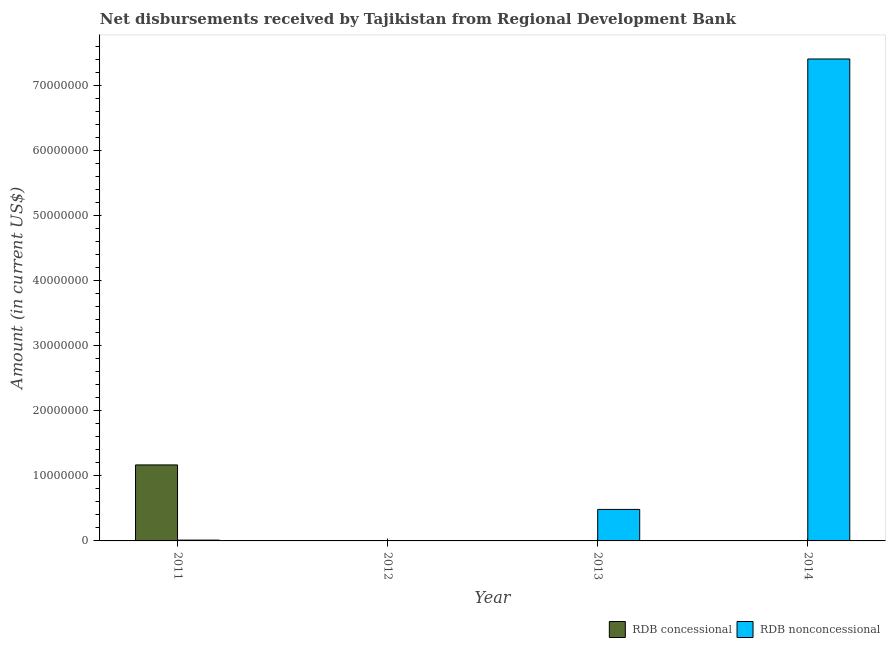Are the number of bars per tick equal to the number of legend labels?
Provide a succinct answer. No. How many bars are there on the 3rd tick from the left?
Ensure brevity in your answer.  1. How many bars are there on the 3rd tick from the right?
Keep it short and to the point. 0. What is the label of the 3rd group of bars from the left?
Offer a very short reply. 2013. Across all years, what is the maximum net non concessional disbursements from rdb?
Your answer should be compact. 7.41e+07. In which year was the net non concessional disbursements from rdb maximum?
Your answer should be compact. 2014. What is the total net concessional disbursements from rdb in the graph?
Give a very brief answer. 1.17e+07. What is the difference between the net non concessional disbursements from rdb in 2011 and that in 2013?
Your response must be concise. -4.72e+06. What is the difference between the net non concessional disbursements from rdb in 2012 and the net concessional disbursements from rdb in 2013?
Offer a terse response. -4.84e+06. What is the average net concessional disbursements from rdb per year?
Your answer should be compact. 2.92e+06. In how many years, is the net non concessional disbursements from rdb greater than 6000000 US$?
Keep it short and to the point. 1. Is the net non concessional disbursements from rdb in 2011 less than that in 2013?
Offer a very short reply. Yes. Is the difference between the net non concessional disbursements from rdb in 2013 and 2014 greater than the difference between the net concessional disbursements from rdb in 2013 and 2014?
Your response must be concise. No. What is the difference between the highest and the second highest net non concessional disbursements from rdb?
Keep it short and to the point. 6.92e+07. What is the difference between the highest and the lowest net non concessional disbursements from rdb?
Give a very brief answer. 7.41e+07. Is the sum of the net non concessional disbursements from rdb in 2011 and 2014 greater than the maximum net concessional disbursements from rdb across all years?
Give a very brief answer. Yes. How many bars are there?
Your answer should be very brief. 4. How many years are there in the graph?
Ensure brevity in your answer.  4. What is the difference between two consecutive major ticks on the Y-axis?
Your answer should be compact. 1.00e+07. Does the graph contain any zero values?
Your response must be concise. Yes. Does the graph contain grids?
Give a very brief answer. No. Where does the legend appear in the graph?
Your answer should be very brief. Bottom right. How are the legend labels stacked?
Give a very brief answer. Horizontal. What is the title of the graph?
Offer a very short reply. Net disbursements received by Tajikistan from Regional Development Bank. What is the label or title of the Y-axis?
Give a very brief answer. Amount (in current US$). What is the Amount (in current US$) of RDB concessional in 2011?
Ensure brevity in your answer.  1.17e+07. What is the Amount (in current US$) of RDB nonconcessional in 2011?
Make the answer very short. 1.25e+05. What is the Amount (in current US$) in RDB nonconcessional in 2012?
Provide a succinct answer. 0. What is the Amount (in current US$) in RDB concessional in 2013?
Provide a succinct answer. 0. What is the Amount (in current US$) of RDB nonconcessional in 2013?
Your response must be concise. 4.84e+06. What is the Amount (in current US$) of RDB nonconcessional in 2014?
Your response must be concise. 7.41e+07. Across all years, what is the maximum Amount (in current US$) in RDB concessional?
Make the answer very short. 1.17e+07. Across all years, what is the maximum Amount (in current US$) in RDB nonconcessional?
Make the answer very short. 7.41e+07. What is the total Amount (in current US$) in RDB concessional in the graph?
Give a very brief answer. 1.17e+07. What is the total Amount (in current US$) of RDB nonconcessional in the graph?
Keep it short and to the point. 7.90e+07. What is the difference between the Amount (in current US$) of RDB nonconcessional in 2011 and that in 2013?
Provide a succinct answer. -4.72e+06. What is the difference between the Amount (in current US$) in RDB nonconcessional in 2011 and that in 2014?
Your answer should be very brief. -7.39e+07. What is the difference between the Amount (in current US$) in RDB nonconcessional in 2013 and that in 2014?
Offer a very short reply. -6.92e+07. What is the difference between the Amount (in current US$) in RDB concessional in 2011 and the Amount (in current US$) in RDB nonconcessional in 2013?
Make the answer very short. 6.84e+06. What is the difference between the Amount (in current US$) in RDB concessional in 2011 and the Amount (in current US$) in RDB nonconcessional in 2014?
Provide a short and direct response. -6.24e+07. What is the average Amount (in current US$) in RDB concessional per year?
Your response must be concise. 2.92e+06. What is the average Amount (in current US$) in RDB nonconcessional per year?
Give a very brief answer. 1.98e+07. In the year 2011, what is the difference between the Amount (in current US$) in RDB concessional and Amount (in current US$) in RDB nonconcessional?
Your answer should be very brief. 1.16e+07. What is the ratio of the Amount (in current US$) of RDB nonconcessional in 2011 to that in 2013?
Your answer should be compact. 0.03. What is the ratio of the Amount (in current US$) of RDB nonconcessional in 2011 to that in 2014?
Offer a very short reply. 0. What is the ratio of the Amount (in current US$) in RDB nonconcessional in 2013 to that in 2014?
Your answer should be compact. 0.07. What is the difference between the highest and the second highest Amount (in current US$) of RDB nonconcessional?
Give a very brief answer. 6.92e+07. What is the difference between the highest and the lowest Amount (in current US$) of RDB concessional?
Ensure brevity in your answer.  1.17e+07. What is the difference between the highest and the lowest Amount (in current US$) in RDB nonconcessional?
Provide a succinct answer. 7.41e+07. 